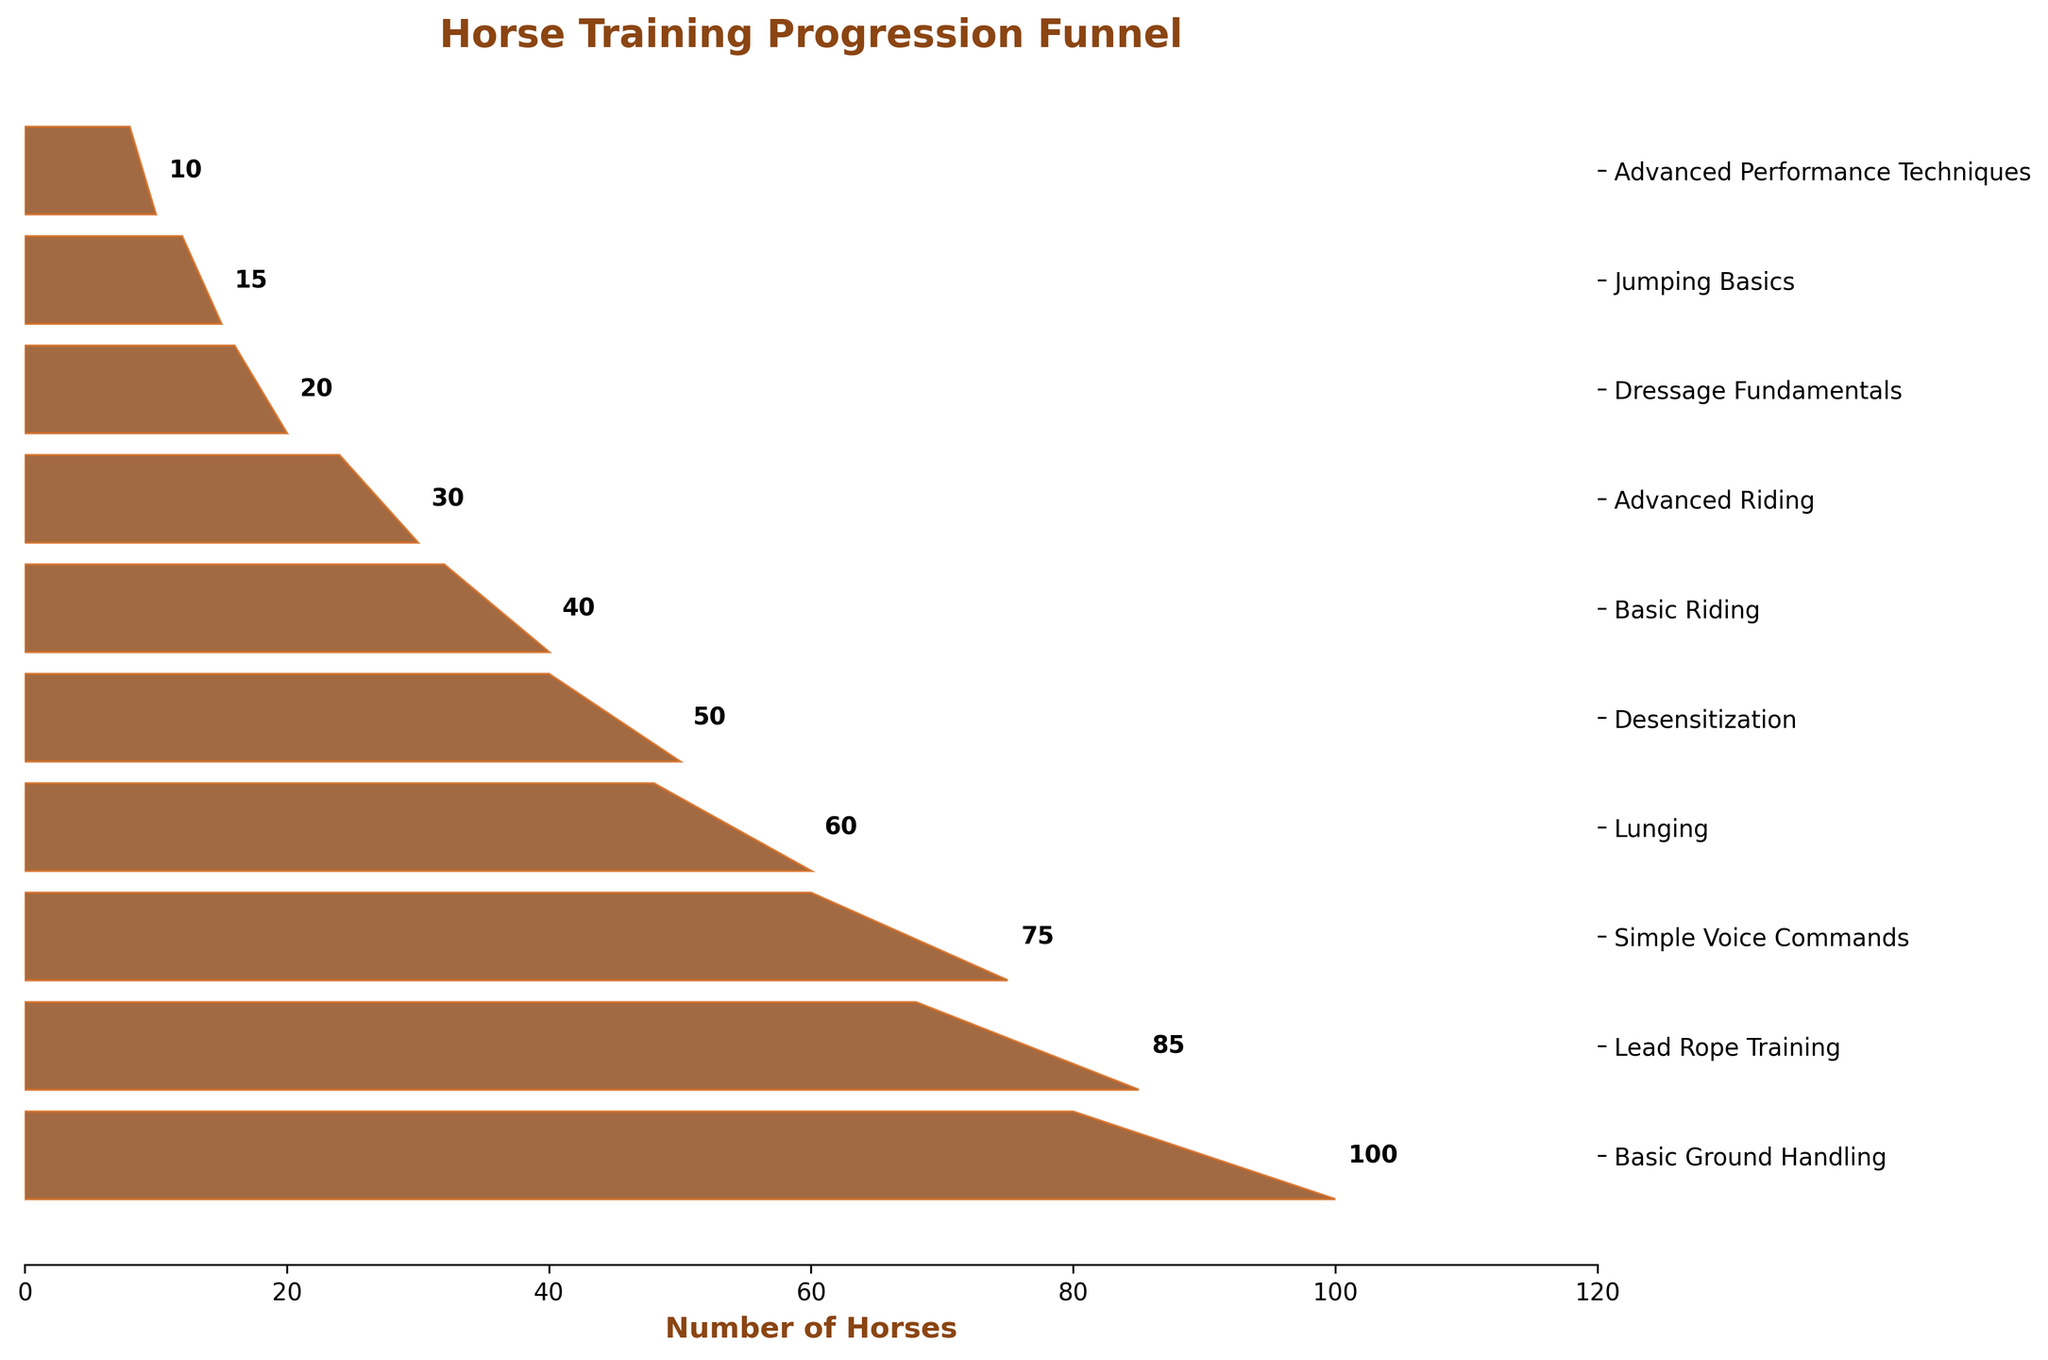What is the title of the chart? The title of the chart is usually found at the top center of the figure and serves to inform the viewer about the content of the chart. In this case, the title is "Horse Training Progression Funnel."
Answer: Horse Training Progression Funnel How many stages are represented in the chart? To find the number of stages, you can count the different labeled stages on the y-axis of the chart. Here, 10 stages are listed, starting from "Basic Ground Handling" to "Advanced Performance Techniques."
Answer: 10 Which training stage has the smallest number of horses? Look at the numerical values next to each stage on the chart and identify the smallest number. "Advanced Performance Techniques" has the smallest number of horses, which is 10.
Answer: Advanced Performance Techniques How many more horses are at the Basic Riding stage compared to the Desensitization stage? Find the values for the "Basic Riding" and "Desensitization" stages (40 and 50, respectively) and subtract the latter from the former: 50 - 40.
Answer: 10 What is the total number of horses from the Lead Rope Training to the Dressage Fundamentals stage? Sum the values from the "Lead Rope Training" stage to the "Dressage Fundamentals" stage which are: 85 + 75 + 60 + 50 + 40 + 30 + 20. The result is 360.
Answer: 360 Which stage shows the largest drop in the number of horses compared to its previous stage? Calculate the differences between consecutive stages: 
Lead Rope Training (85) - Basic Ground Handling (100) = -15,
Simple Voice Commands (75) - Lead Rope Training (85) = -10,
Lunging (60) - Simple Voice Commands (75) = -15,
Desensitization (50) - Lunging (60) = -10,
Basic Riding (40) - Desensitization (50) = -10,
Advanced Riding (30) - Basic Riding (40) = -10,
Dressage Fundamentals (20) - Advanced Riding (30) = -10,
Jumping Basics (15) - Dressage Fundamentals (20) = -5,
Advanced Performance Techniques (10) - Jumping Basics (15) = -5.
The largest drop is from "Simple Voice Commands" to "Lunging" with a decrease of 15 horses.
Answer: Lunging What's the average number of horses across all stages? Sum the number of horses for all stages: 100 + 85 + 75 + 60 + 50 + 40 + 30 + 20 + 15 + 10 = 485. Next, divide this sum by the number of stages, which is 10. The result is 48.5.
Answer: 48.5 Which training stages have more than 50 horses? Look at the values next to each stage and identify those greater than 50. The stages are:
"Basic Ground Handling" (100), "Lead Rope Training" (85), "Simple Voice Commands" (75), and "Lunging" (60).
Answer: Basic Ground Handling, Lead Rope Training, Simple Voice Commands, Lunging 